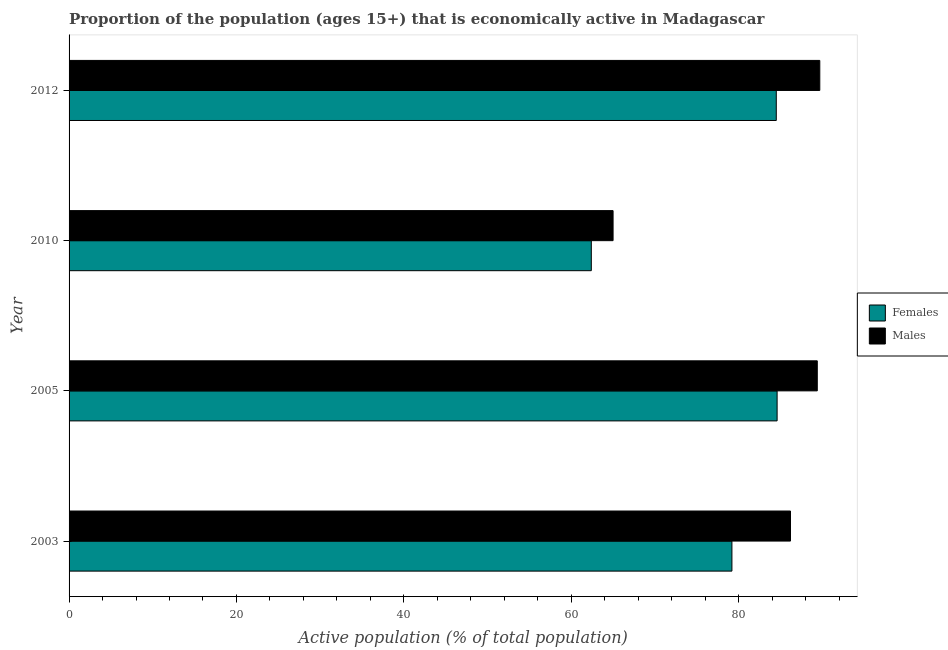How many different coloured bars are there?
Provide a short and direct response. 2. Are the number of bars per tick equal to the number of legend labels?
Provide a succinct answer. Yes. Are the number of bars on each tick of the Y-axis equal?
Your answer should be very brief. Yes. What is the label of the 1st group of bars from the top?
Keep it short and to the point. 2012. Across all years, what is the maximum percentage of economically active male population?
Keep it short and to the point. 89.7. Across all years, what is the minimum percentage of economically active male population?
Give a very brief answer. 65. In which year was the percentage of economically active male population maximum?
Offer a very short reply. 2012. In which year was the percentage of economically active female population minimum?
Your answer should be very brief. 2010. What is the total percentage of economically active male population in the graph?
Keep it short and to the point. 330.3. What is the difference between the percentage of economically active male population in 2003 and that in 2005?
Ensure brevity in your answer.  -3.2. What is the difference between the percentage of economically active male population in 2003 and the percentage of economically active female population in 2005?
Your answer should be very brief. 1.6. What is the average percentage of economically active male population per year?
Your response must be concise. 82.58. What is the ratio of the percentage of economically active male population in 2003 to that in 2012?
Keep it short and to the point. 0.96. Is the difference between the percentage of economically active female population in 2003 and 2010 greater than the difference between the percentage of economically active male population in 2003 and 2010?
Your response must be concise. No. What is the difference between the highest and the lowest percentage of economically active female population?
Provide a short and direct response. 22.2. What does the 1st bar from the top in 2005 represents?
Offer a very short reply. Males. What does the 2nd bar from the bottom in 2012 represents?
Offer a very short reply. Males. Are all the bars in the graph horizontal?
Provide a succinct answer. Yes. What is the difference between two consecutive major ticks on the X-axis?
Your response must be concise. 20. Are the values on the major ticks of X-axis written in scientific E-notation?
Keep it short and to the point. No. Does the graph contain any zero values?
Provide a short and direct response. No. Does the graph contain grids?
Offer a very short reply. No. How many legend labels are there?
Offer a terse response. 2. What is the title of the graph?
Ensure brevity in your answer.  Proportion of the population (ages 15+) that is economically active in Madagascar. Does "Primary education" appear as one of the legend labels in the graph?
Offer a terse response. No. What is the label or title of the X-axis?
Make the answer very short. Active population (% of total population). What is the label or title of the Y-axis?
Ensure brevity in your answer.  Year. What is the Active population (% of total population) in Females in 2003?
Offer a terse response. 79.2. What is the Active population (% of total population) of Males in 2003?
Offer a terse response. 86.2. What is the Active population (% of total population) in Females in 2005?
Ensure brevity in your answer.  84.6. What is the Active population (% of total population) of Males in 2005?
Keep it short and to the point. 89.4. What is the Active population (% of total population) in Females in 2010?
Provide a short and direct response. 62.4. What is the Active population (% of total population) in Males in 2010?
Your answer should be compact. 65. What is the Active population (% of total population) of Females in 2012?
Your answer should be compact. 84.5. What is the Active population (% of total population) of Males in 2012?
Offer a terse response. 89.7. Across all years, what is the maximum Active population (% of total population) of Females?
Give a very brief answer. 84.6. Across all years, what is the maximum Active population (% of total population) in Males?
Ensure brevity in your answer.  89.7. Across all years, what is the minimum Active population (% of total population) in Females?
Ensure brevity in your answer.  62.4. What is the total Active population (% of total population) in Females in the graph?
Provide a short and direct response. 310.7. What is the total Active population (% of total population) of Males in the graph?
Your answer should be compact. 330.3. What is the difference between the Active population (% of total population) in Females in 2003 and that in 2005?
Offer a very short reply. -5.4. What is the difference between the Active population (% of total population) of Males in 2003 and that in 2010?
Your answer should be compact. 21.2. What is the difference between the Active population (% of total population) in Females in 2005 and that in 2010?
Make the answer very short. 22.2. What is the difference between the Active population (% of total population) in Males in 2005 and that in 2010?
Your answer should be compact. 24.4. What is the difference between the Active population (% of total population) in Females in 2005 and that in 2012?
Keep it short and to the point. 0.1. What is the difference between the Active population (% of total population) in Males in 2005 and that in 2012?
Your response must be concise. -0.3. What is the difference between the Active population (% of total population) in Females in 2010 and that in 2012?
Make the answer very short. -22.1. What is the difference between the Active population (% of total population) of Males in 2010 and that in 2012?
Your answer should be very brief. -24.7. What is the difference between the Active population (% of total population) in Females in 2003 and the Active population (% of total population) in Males in 2010?
Keep it short and to the point. 14.2. What is the difference between the Active population (% of total population) in Females in 2005 and the Active population (% of total population) in Males in 2010?
Your answer should be very brief. 19.6. What is the difference between the Active population (% of total population) in Females in 2005 and the Active population (% of total population) in Males in 2012?
Your answer should be very brief. -5.1. What is the difference between the Active population (% of total population) of Females in 2010 and the Active population (% of total population) of Males in 2012?
Your answer should be very brief. -27.3. What is the average Active population (% of total population) of Females per year?
Make the answer very short. 77.67. What is the average Active population (% of total population) of Males per year?
Ensure brevity in your answer.  82.58. In the year 2003, what is the difference between the Active population (% of total population) in Females and Active population (% of total population) in Males?
Your response must be concise. -7. In the year 2005, what is the difference between the Active population (% of total population) of Females and Active population (% of total population) of Males?
Make the answer very short. -4.8. What is the ratio of the Active population (% of total population) of Females in 2003 to that in 2005?
Your answer should be very brief. 0.94. What is the ratio of the Active population (% of total population) in Males in 2003 to that in 2005?
Your answer should be very brief. 0.96. What is the ratio of the Active population (% of total population) in Females in 2003 to that in 2010?
Give a very brief answer. 1.27. What is the ratio of the Active population (% of total population) of Males in 2003 to that in 2010?
Your response must be concise. 1.33. What is the ratio of the Active population (% of total population) in Females in 2003 to that in 2012?
Keep it short and to the point. 0.94. What is the ratio of the Active population (% of total population) in Females in 2005 to that in 2010?
Your response must be concise. 1.36. What is the ratio of the Active population (% of total population) in Males in 2005 to that in 2010?
Provide a succinct answer. 1.38. What is the ratio of the Active population (% of total population) of Females in 2005 to that in 2012?
Give a very brief answer. 1. What is the ratio of the Active population (% of total population) of Males in 2005 to that in 2012?
Keep it short and to the point. 1. What is the ratio of the Active population (% of total population) of Females in 2010 to that in 2012?
Make the answer very short. 0.74. What is the ratio of the Active population (% of total population) in Males in 2010 to that in 2012?
Keep it short and to the point. 0.72. What is the difference between the highest and the lowest Active population (% of total population) in Females?
Give a very brief answer. 22.2. What is the difference between the highest and the lowest Active population (% of total population) of Males?
Offer a very short reply. 24.7. 